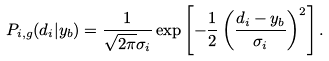Convert formula to latex. <formula><loc_0><loc_0><loc_500><loc_500>P _ { i , g } ( d _ { i } | y _ { b } ) = \frac { 1 } { \sqrt { 2 \pi } \sigma _ { i } } \exp \left [ - \frac { 1 } { 2 } \left ( \frac { d _ { i } - y _ { b } } { \sigma _ { i } } \right ) ^ { 2 } \right ] .</formula> 